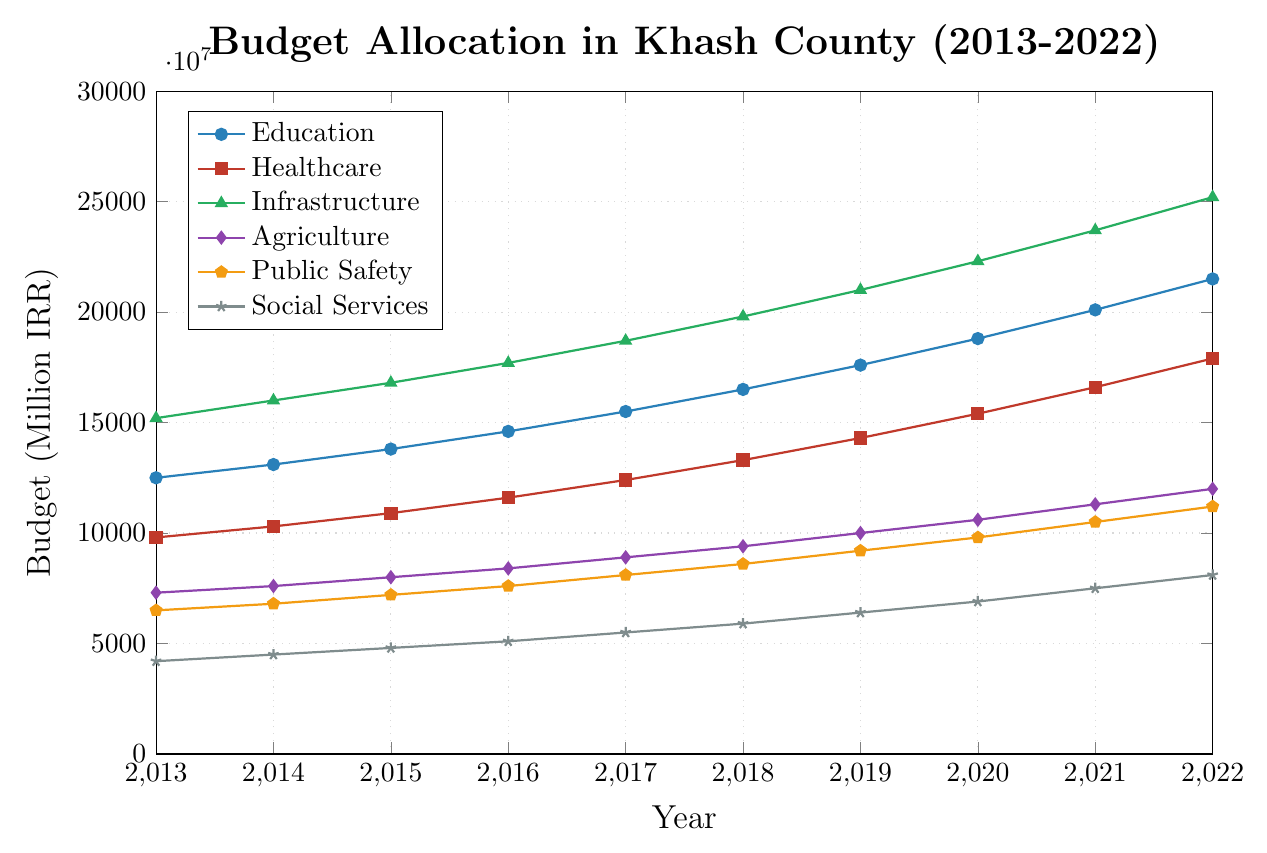Which sector received the highest budget allocation in 2022? The figure shows that the `Infrastructure` sector has the highest data point in 2022, indicating the highest budget allocation.
Answer: Infrastructure What is the total budget allocation for Education and Healthcare in 2015? Adding the budget allocations for Education (13,800,000) and Healthcare (10,900,000) in 2015 gives 24,700,000.
Answer: 24,700,000 By how much did the budget for Public Safety increase from 2018 to 2022? The budget for Public Safety in 2018 is 8,600,000 and in 2022 is 11,200,000. The increase is 11,200,000 - 8,600,000 = 2,600,000.
Answer: 2,600,000 In which year does the Education sector surpass 20 million IRR in budget allocation? The Education sector surpasses 20 million IRR in 2021 with a budget of 20,100,000.
Answer: 2021 Among the sectors displayed, which one experienced the smallest budget increase over the decade (2013-2022)? Subtracting the 2013 budget from the 2022 budget for each sector, `Agriculture` shows the smallest increase (12,000,000 - 7,300,000 = 4,700,000).
Answer: Agriculture Compare the budget growth rate of Healthcare and Social Services between 2017 and 2020 in terms of percentage. Healthcare: (15,400,000 - 12,400,000) / 12,400,000 * 100 = 24.19% 
Social Services: (6,900,000 - 5,500,000) / 5,500,000 * 100 = 25.45%
Therefore, Social Services had a higher growth rate.
Answer: Social Services What is the overall trend in budget allocation for Infrastructure from 2013 to 2022? The figure shows a consistent upward trend in the budget allocation for Infrastructure every year from 2013 to 2022.
Answer: Upward trend Which sector had the second-highest budget allocation in 2016? Only the `Infrastructure` and `Education` sectors surpass other sectors in 2016, with Infrastructure higher than Education. Hence, `Education` had the second-highest budget.
Answer: Education How does the 2020 budget for Agriculture compare to the 2013 budget for Education? The 2020 budget for Agriculture is 10,600,000 and the 2013 budget for Education is 12,500,000. Agriculture's budget is less than Education's budget in 2013.
Answer: Less What are the differences in the yearly increase of budget allocation for Public Safety between the years 2017-2018 and 2021-2022? From 2017 to 2018, Public Safety increased by 860,000 - 810,000 = 500,000, and from 2021 to 2022, it increased by 11,200,000 - 10,500,000 = 700,000. The differences are 500,000 and 700,000 respectively.
Answer: 500,000 and 700,000 